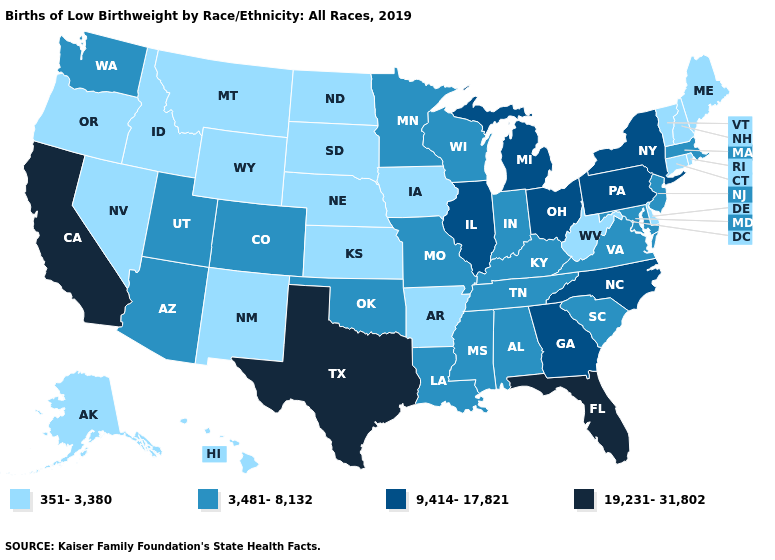Among the states that border Pennsylvania , does New York have the highest value?
Quick response, please. Yes. What is the highest value in the West ?
Short answer required. 19,231-31,802. Among the states that border New Hampshire , which have the highest value?
Write a very short answer. Massachusetts. Name the states that have a value in the range 19,231-31,802?
Answer briefly. California, Florida, Texas. What is the highest value in the West ?
Answer briefly. 19,231-31,802. What is the highest value in states that border New York?
Keep it brief. 9,414-17,821. Among the states that border Maine , which have the highest value?
Quick response, please. New Hampshire. Among the states that border West Virginia , does Maryland have the lowest value?
Give a very brief answer. Yes. What is the value of Alaska?
Short answer required. 351-3,380. Among the states that border Oklahoma , does Texas have the highest value?
Answer briefly. Yes. Among the states that border Virginia , does West Virginia have the lowest value?
Write a very short answer. Yes. What is the lowest value in states that border Alabama?
Short answer required. 3,481-8,132. What is the value of Maine?
Quick response, please. 351-3,380. Which states hav the highest value in the Northeast?
Write a very short answer. New York, Pennsylvania. Does Florida have the highest value in the South?
Give a very brief answer. Yes. 